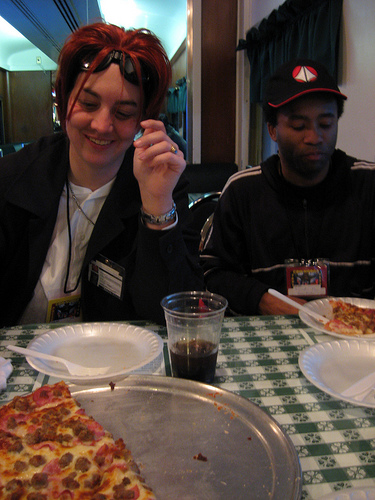<image>
Is the pizza on the plate? Yes. Looking at the image, I can see the pizza is positioned on top of the plate, with the plate providing support. Is there a hat on the woman? No. The hat is not positioned on the woman. They may be near each other, but the hat is not supported by or resting on top of the woman. Is there a platter under the sunglasses? No. The platter is not positioned under the sunglasses. The vertical relationship between these objects is different. Is the fork next to the plate? No. The fork is not positioned next to the plate. They are located in different areas of the scene. Where is the fork in relation to the plate? Is it above the plate? Yes. The fork is positioned above the plate in the vertical space, higher up in the scene. 